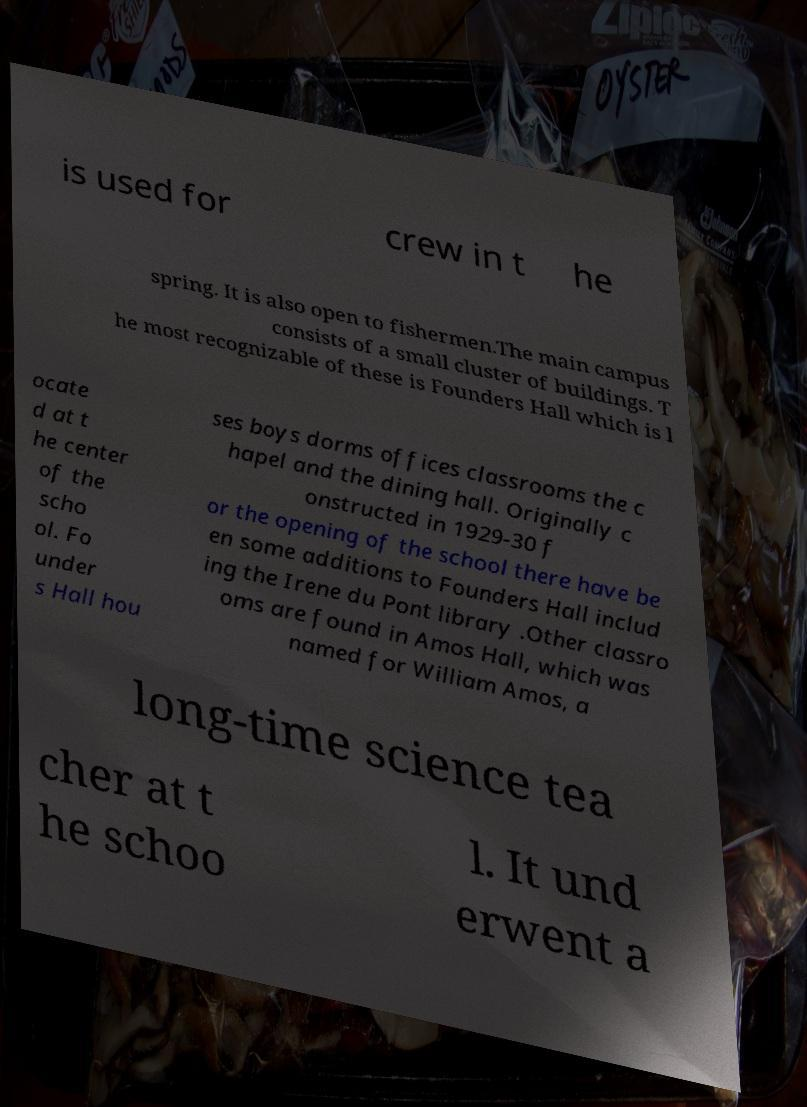Can you read and provide the text displayed in the image?This photo seems to have some interesting text. Can you extract and type it out for me? is used for crew in t he spring. It is also open to fishermen.The main campus consists of a small cluster of buildings. T he most recognizable of these is Founders Hall which is l ocate d at t he center of the scho ol. Fo under s Hall hou ses boys dorms offices classrooms the c hapel and the dining hall. Originally c onstructed in 1929-30 f or the opening of the school there have be en some additions to Founders Hall includ ing the Irene du Pont library .Other classro oms are found in Amos Hall, which was named for William Amos, a long-time science tea cher at t he schoo l. It und erwent a 